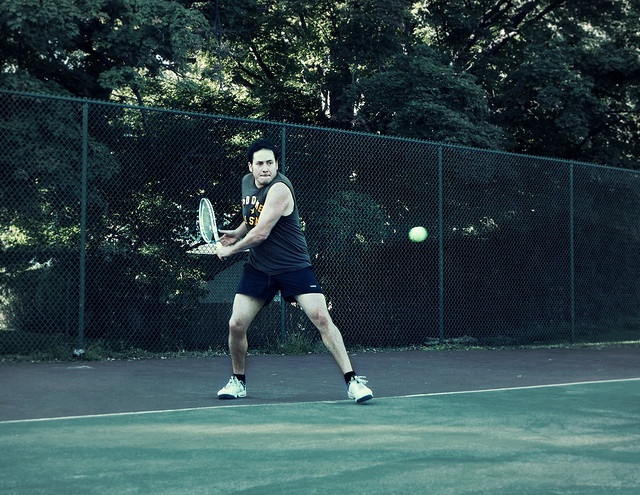Describe the objects in this image and their specific colors. I can see people in black, lightgray, darkgray, and gray tones, tennis racket in black, ivory, teal, lightblue, and turquoise tones, and sports ball in black, beige, lightgreen, turquoise, and teal tones in this image. 